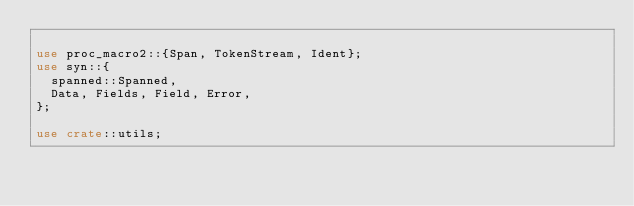Convert code to text. <code><loc_0><loc_0><loc_500><loc_500><_Rust_>
use proc_macro2::{Span, TokenStream, Ident};
use syn::{
	spanned::Spanned,
	Data, Fields, Field, Error,
};

use crate::utils;
</code> 